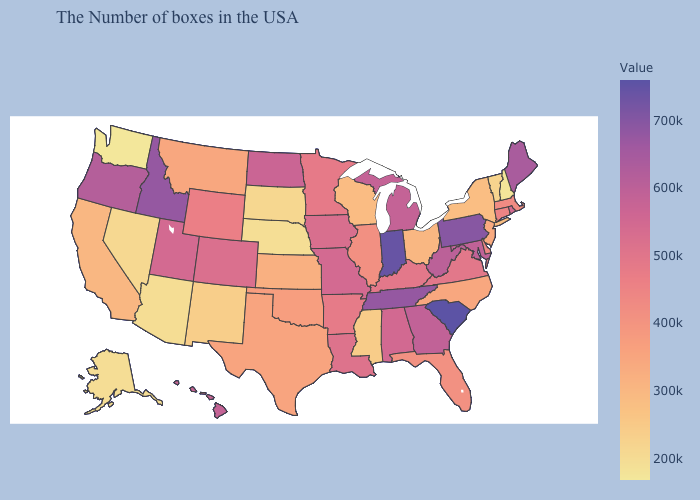Among the states that border Georgia , does South Carolina have the highest value?
Answer briefly. Yes. Does Minnesota have a higher value than New Hampshire?
Write a very short answer. Yes. Does Washington have a higher value than Massachusetts?
Write a very short answer. No. Does the map have missing data?
Concise answer only. No. Does South Dakota have the lowest value in the USA?
Short answer required. No. 